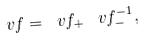<formula> <loc_0><loc_0><loc_500><loc_500>\ v f = \ v f _ { + } \, \ v f _ { - } ^ { - 1 } ,</formula> 